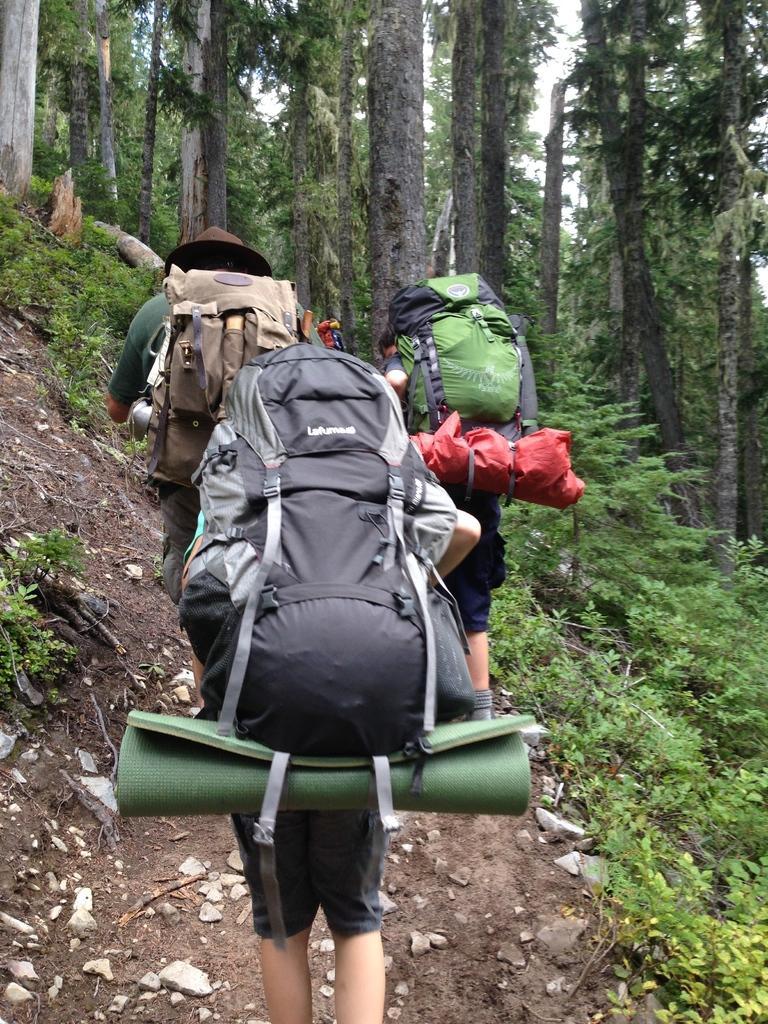Could you give a brief overview of what you see in this image? There are three persons in this image who is trekking and at the background there are trees. 